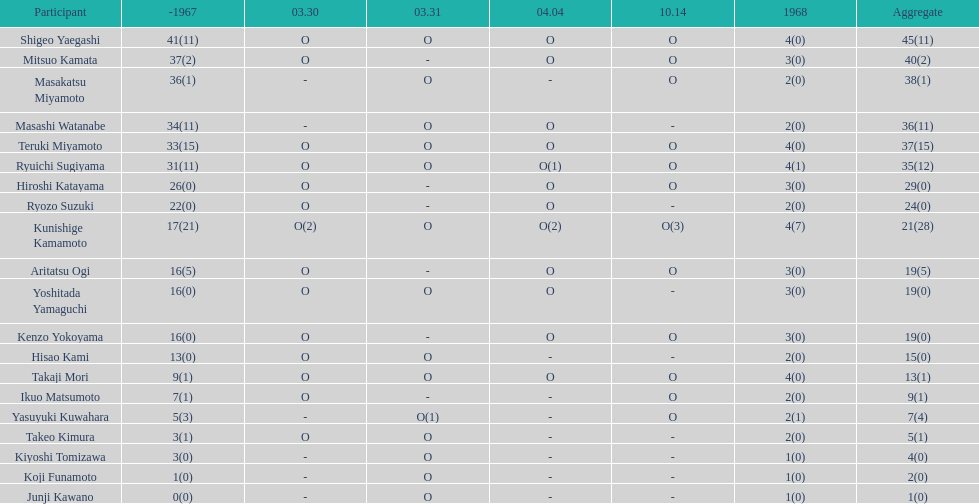How many more total appearances did shigeo yaegashi have than mitsuo kamata? 5. 